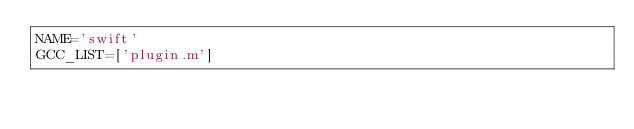<code> <loc_0><loc_0><loc_500><loc_500><_Python_>NAME='swift'
GCC_LIST=['plugin.m']
</code> 